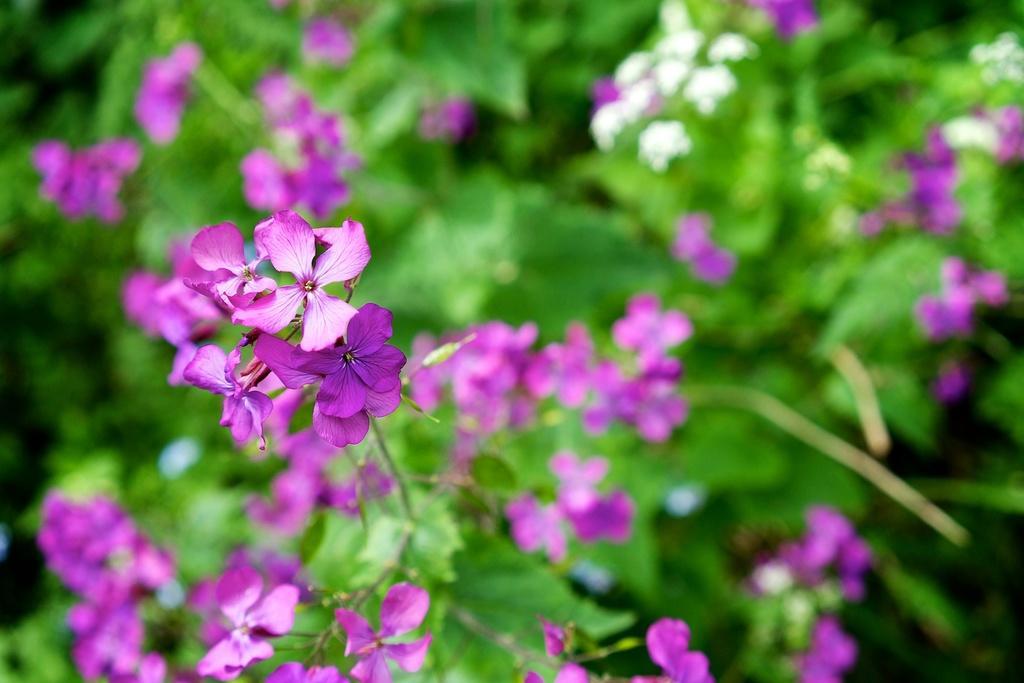Describe this image in one or two sentences. In this image there is a zoom in picture of some flowers on the left side of this image. 